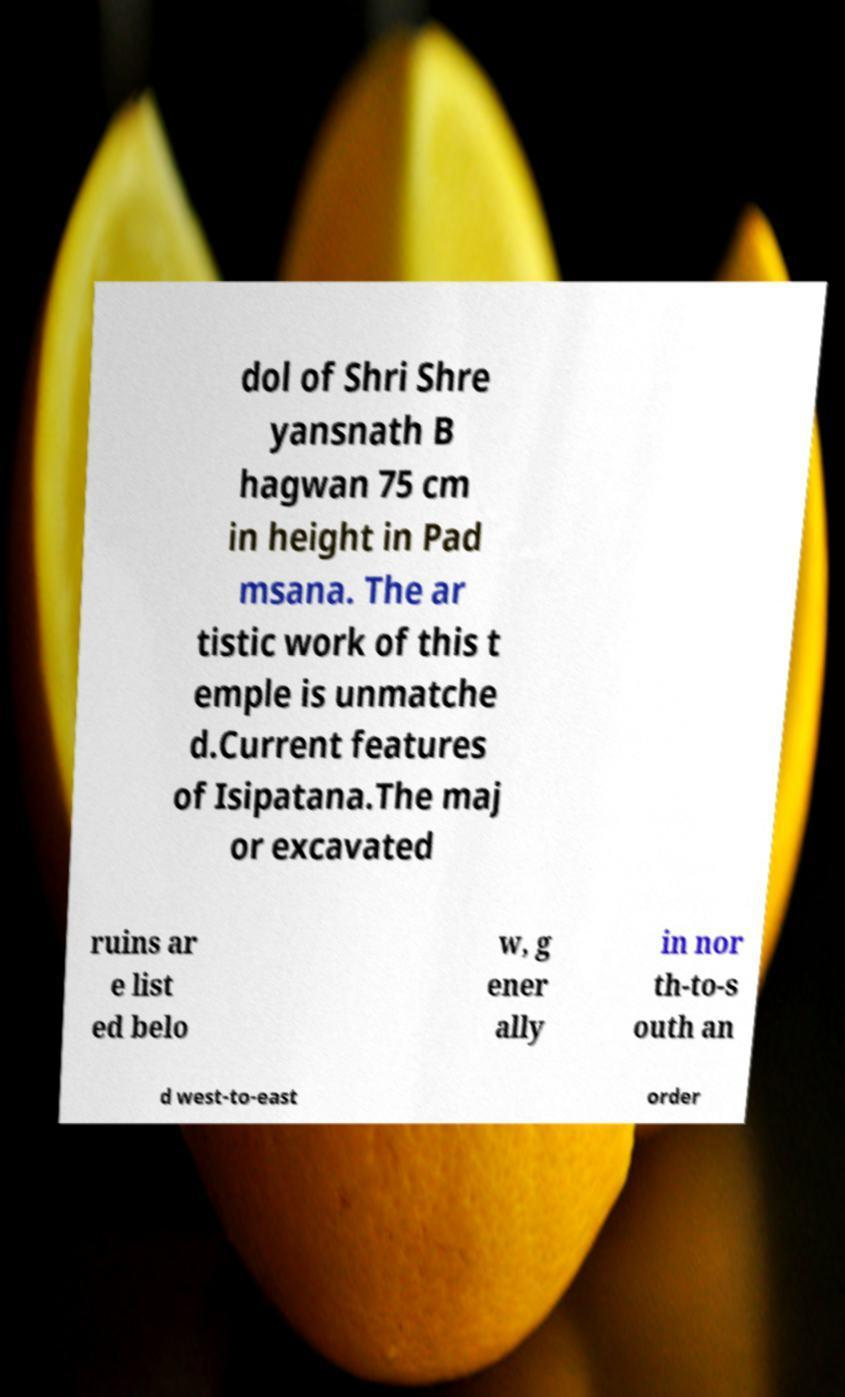There's text embedded in this image that I need extracted. Can you transcribe it verbatim? dol of Shri Shre yansnath B hagwan 75 cm in height in Pad msana. The ar tistic work of this t emple is unmatche d.Current features of Isipatana.The maj or excavated ruins ar e list ed belo w, g ener ally in nor th-to-s outh an d west-to-east order 